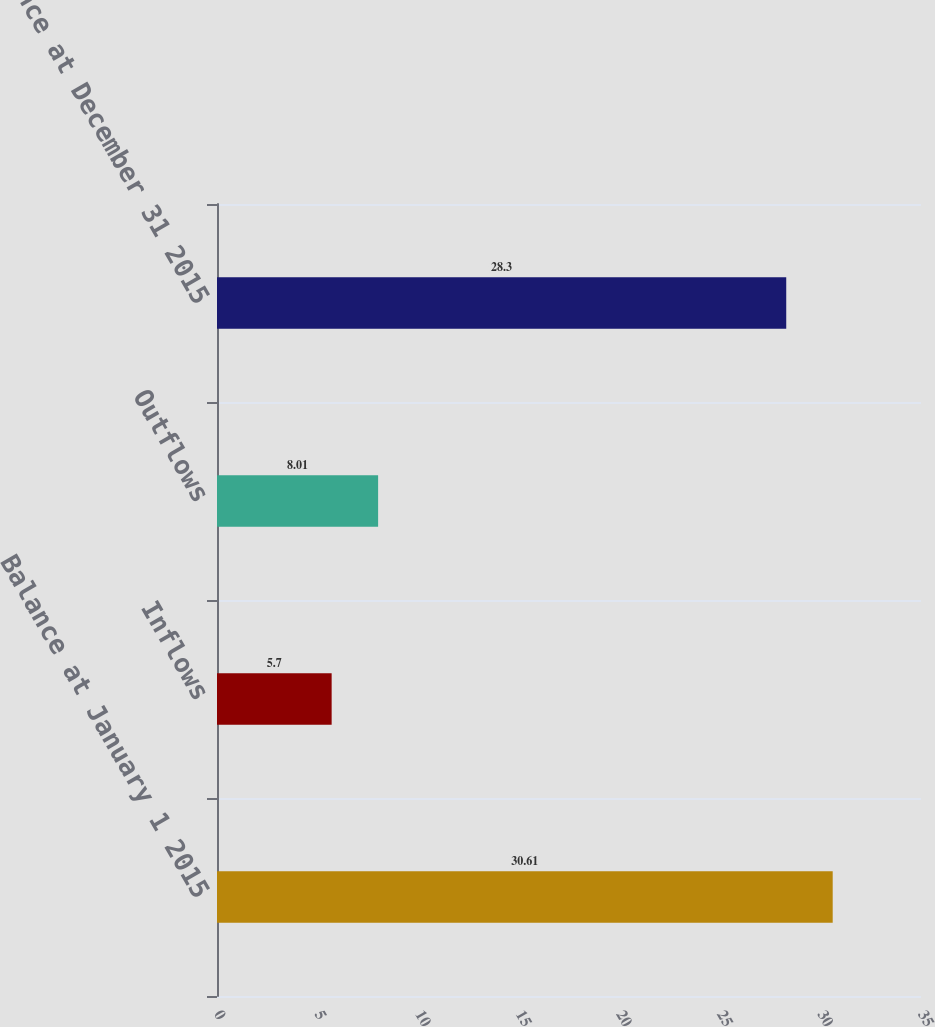Convert chart. <chart><loc_0><loc_0><loc_500><loc_500><bar_chart><fcel>Balance at January 1 2015<fcel>Inflows<fcel>Outflows<fcel>Balance at December 31 2015<nl><fcel>30.61<fcel>5.7<fcel>8.01<fcel>28.3<nl></chart> 